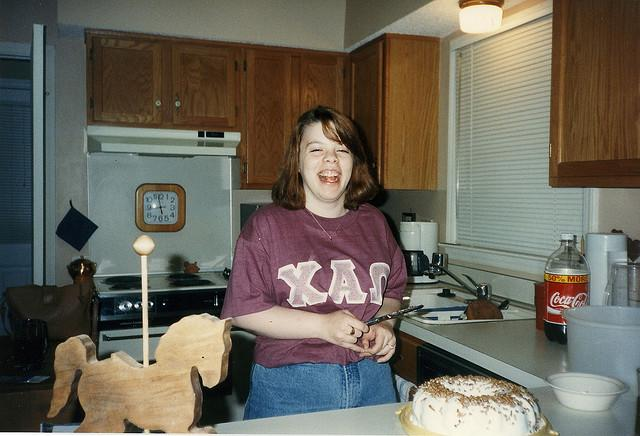What soda does she like to drink? Please explain your reasoning. coca-cola. There is a bottle of one brand of soda on the counter but none of the others. 